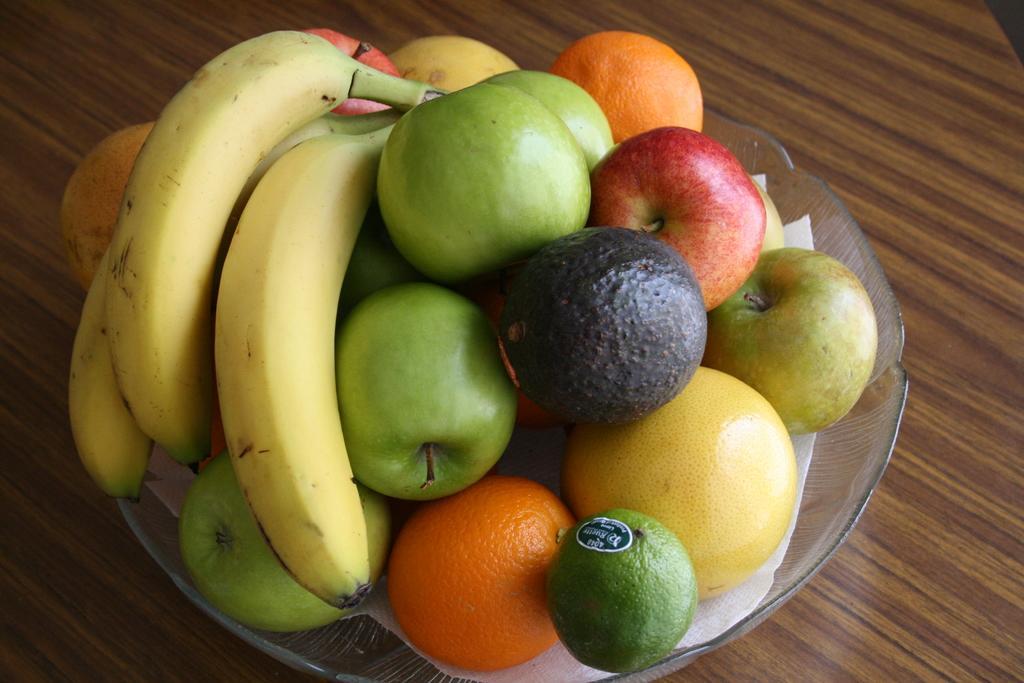How would you summarize this image in a sentence or two? In this image I can see there are fruits in a bowl. 